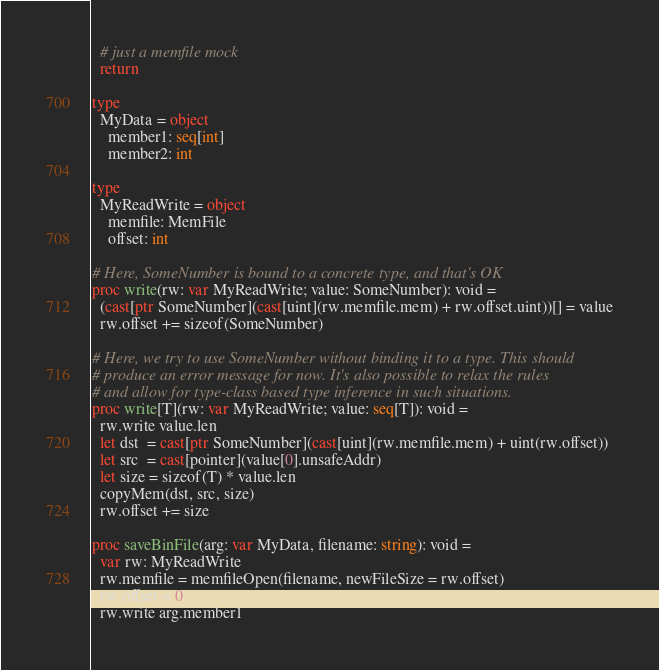Convert code to text. <code><loc_0><loc_0><loc_500><loc_500><_Nim_>  # just a memfile mock
  return

type
  MyData = object
    member1: seq[int]
    member2: int

type
  MyReadWrite = object
    memfile: MemFile
    offset: int

# Here, SomeNumber is bound to a concrete type, and that's OK
proc write(rw: var MyReadWrite; value: SomeNumber): void =
  (cast[ptr SomeNumber](cast[uint](rw.memfile.mem) + rw.offset.uint))[] = value
  rw.offset += sizeof(SomeNumber)

# Here, we try to use SomeNumber without binding it to a type. This should
# produce an error message for now. It's also possible to relax the rules
# and allow for type-class based type inference in such situations.
proc write[T](rw: var MyReadWrite; value: seq[T]): void =
  rw.write value.len
  let dst  = cast[ptr SomeNumber](cast[uint](rw.memfile.mem) + uint(rw.offset))
  let src  = cast[pointer](value[0].unsafeAddr)
  let size = sizeof(T) * value.len
  copyMem(dst, src, size)
  rw.offset += size

proc saveBinFile(arg: var MyData, filename: string): void =
  var rw: MyReadWrite
  rw.memfile = memfileOpen(filename, newFileSize = rw.offset)
  rw.offset = 0
  rw.write arg.member1

</code> 